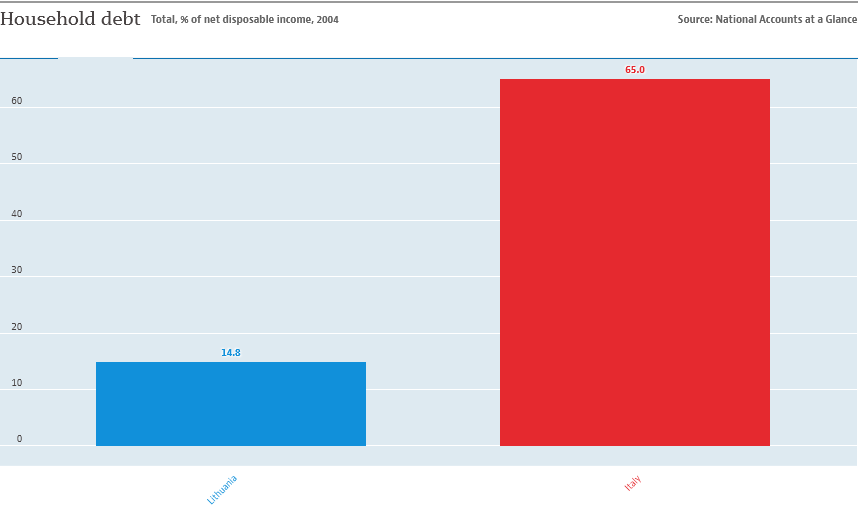Highlight a few significant elements in this photo. The total value of the two bars is 79.8... There are two categories in the chart. 